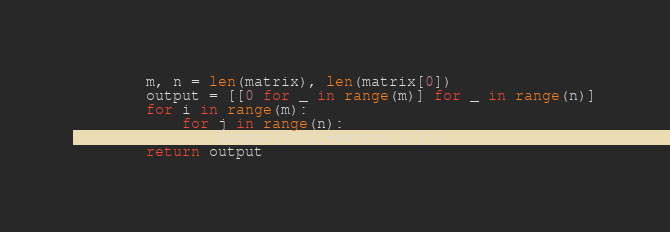Convert code to text. <code><loc_0><loc_0><loc_500><loc_500><_Python_>        m, n = len(matrix), len(matrix[0])
        output = [[0 for _ in range(m)] for _ in range(n)]
        for i in range(m):
            for j in range(n):
                output[j][i]=matrix[i][j]
        return output</code> 